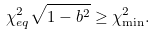Convert formula to latex. <formula><loc_0><loc_0><loc_500><loc_500>\chi _ { e q } ^ { 2 } \sqrt { 1 - b ^ { 2 } } \geq \chi _ { \min } ^ { 2 } .</formula> 